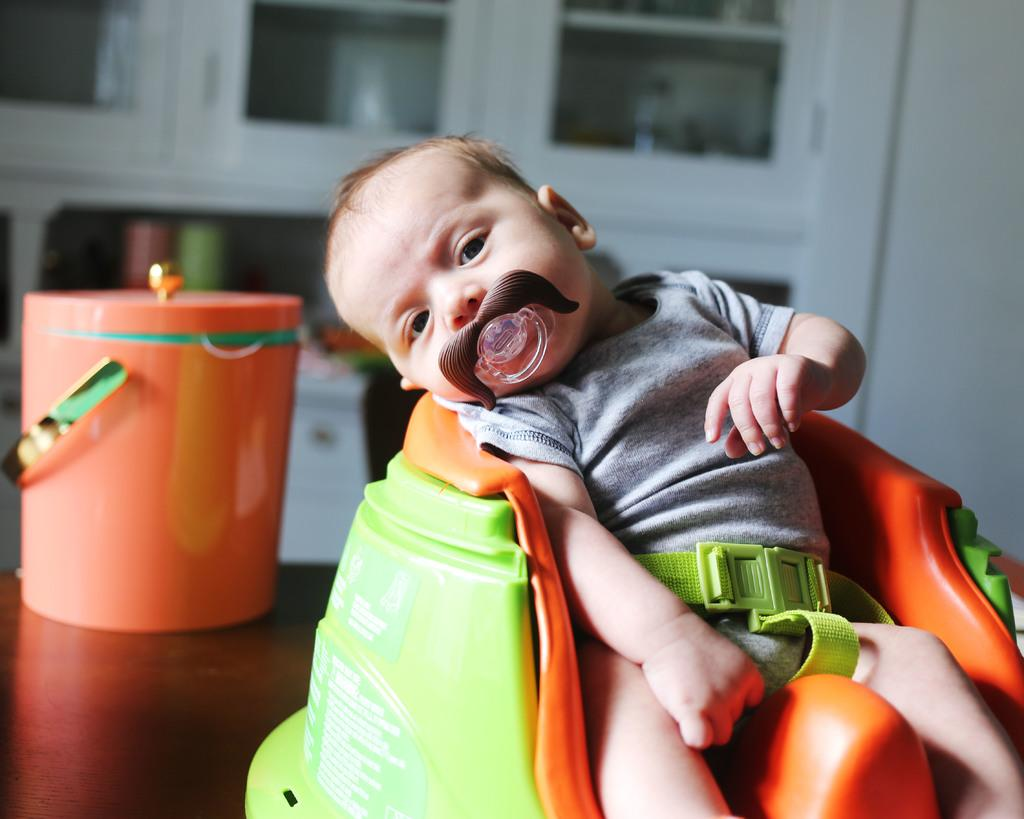What is the main subject of the image? There is a baby in the image. What can be seen in the background of the image? There are cupboards and a wall in the background of the image. Can you describe an object that is on a surface in the image? There is a bucket on a surface in the image. What type of juice is the giant drinking in the image? There is no giant or juice present in the image. 